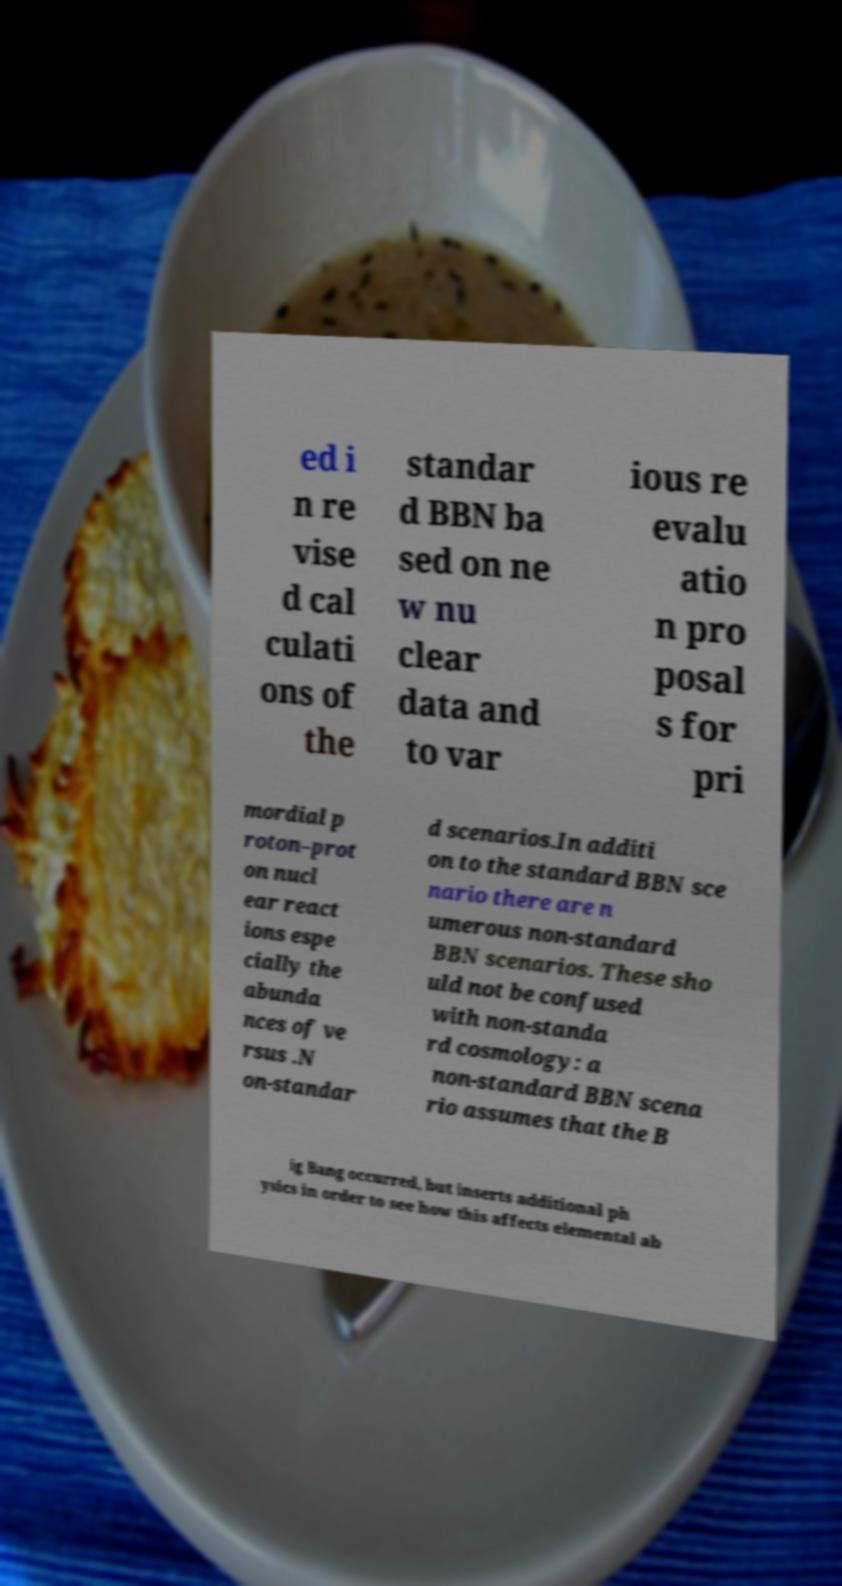There's text embedded in this image that I need extracted. Can you transcribe it verbatim? ed i n re vise d cal culati ons of the standar d BBN ba sed on ne w nu clear data and to var ious re evalu atio n pro posal s for pri mordial p roton–prot on nucl ear react ions espe cially the abunda nces of ve rsus .N on-standar d scenarios.In additi on to the standard BBN sce nario there are n umerous non-standard BBN scenarios. These sho uld not be confused with non-standa rd cosmology: a non-standard BBN scena rio assumes that the B ig Bang occurred, but inserts additional ph ysics in order to see how this affects elemental ab 